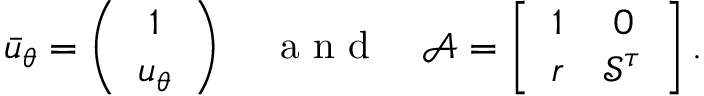<formula> <loc_0><loc_0><loc_500><loc_500>\bar { u } _ { \theta } = \left ( \begin{array} { c } { 1 } \\ { u _ { \theta } } \end{array} \right ) \quad a n d \quad \mathcal { A } = \left [ \begin{array} { c c } { 1 } & { 0 } \\ { r } & { \mathcal { S } ^ { \tau } } \end{array} \right ] .</formula> 